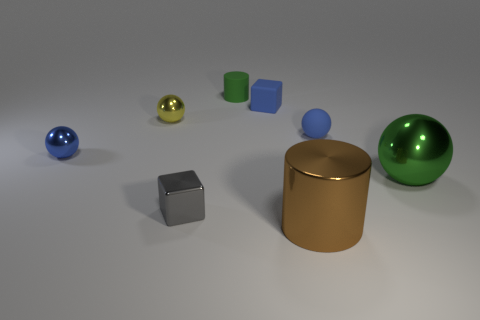What material is the large ball that is the same color as the small matte cylinder?
Provide a succinct answer. Metal. What number of tiny objects are either metal spheres or yellow shiny cylinders?
Your response must be concise. 2. The yellow shiny thing that is the same size as the green rubber cylinder is what shape?
Provide a succinct answer. Sphere. Is there anything else that has the same size as the green ball?
Your response must be concise. Yes. What material is the large thing in front of the large metal object on the right side of the brown cylinder?
Ensure brevity in your answer.  Metal. Do the yellow object and the brown object have the same size?
Offer a very short reply. No. What number of objects are tiny blue things that are in front of the blue rubber block or small blue rubber things?
Offer a terse response. 3. There is a thing that is behind the tiny cube behind the big green shiny sphere; what is its shape?
Provide a succinct answer. Cylinder. Is the size of the metal cube the same as the cylinder in front of the large green metallic object?
Provide a short and direct response. No. There is a small block right of the tiny gray thing; what material is it?
Provide a short and direct response. Rubber. 